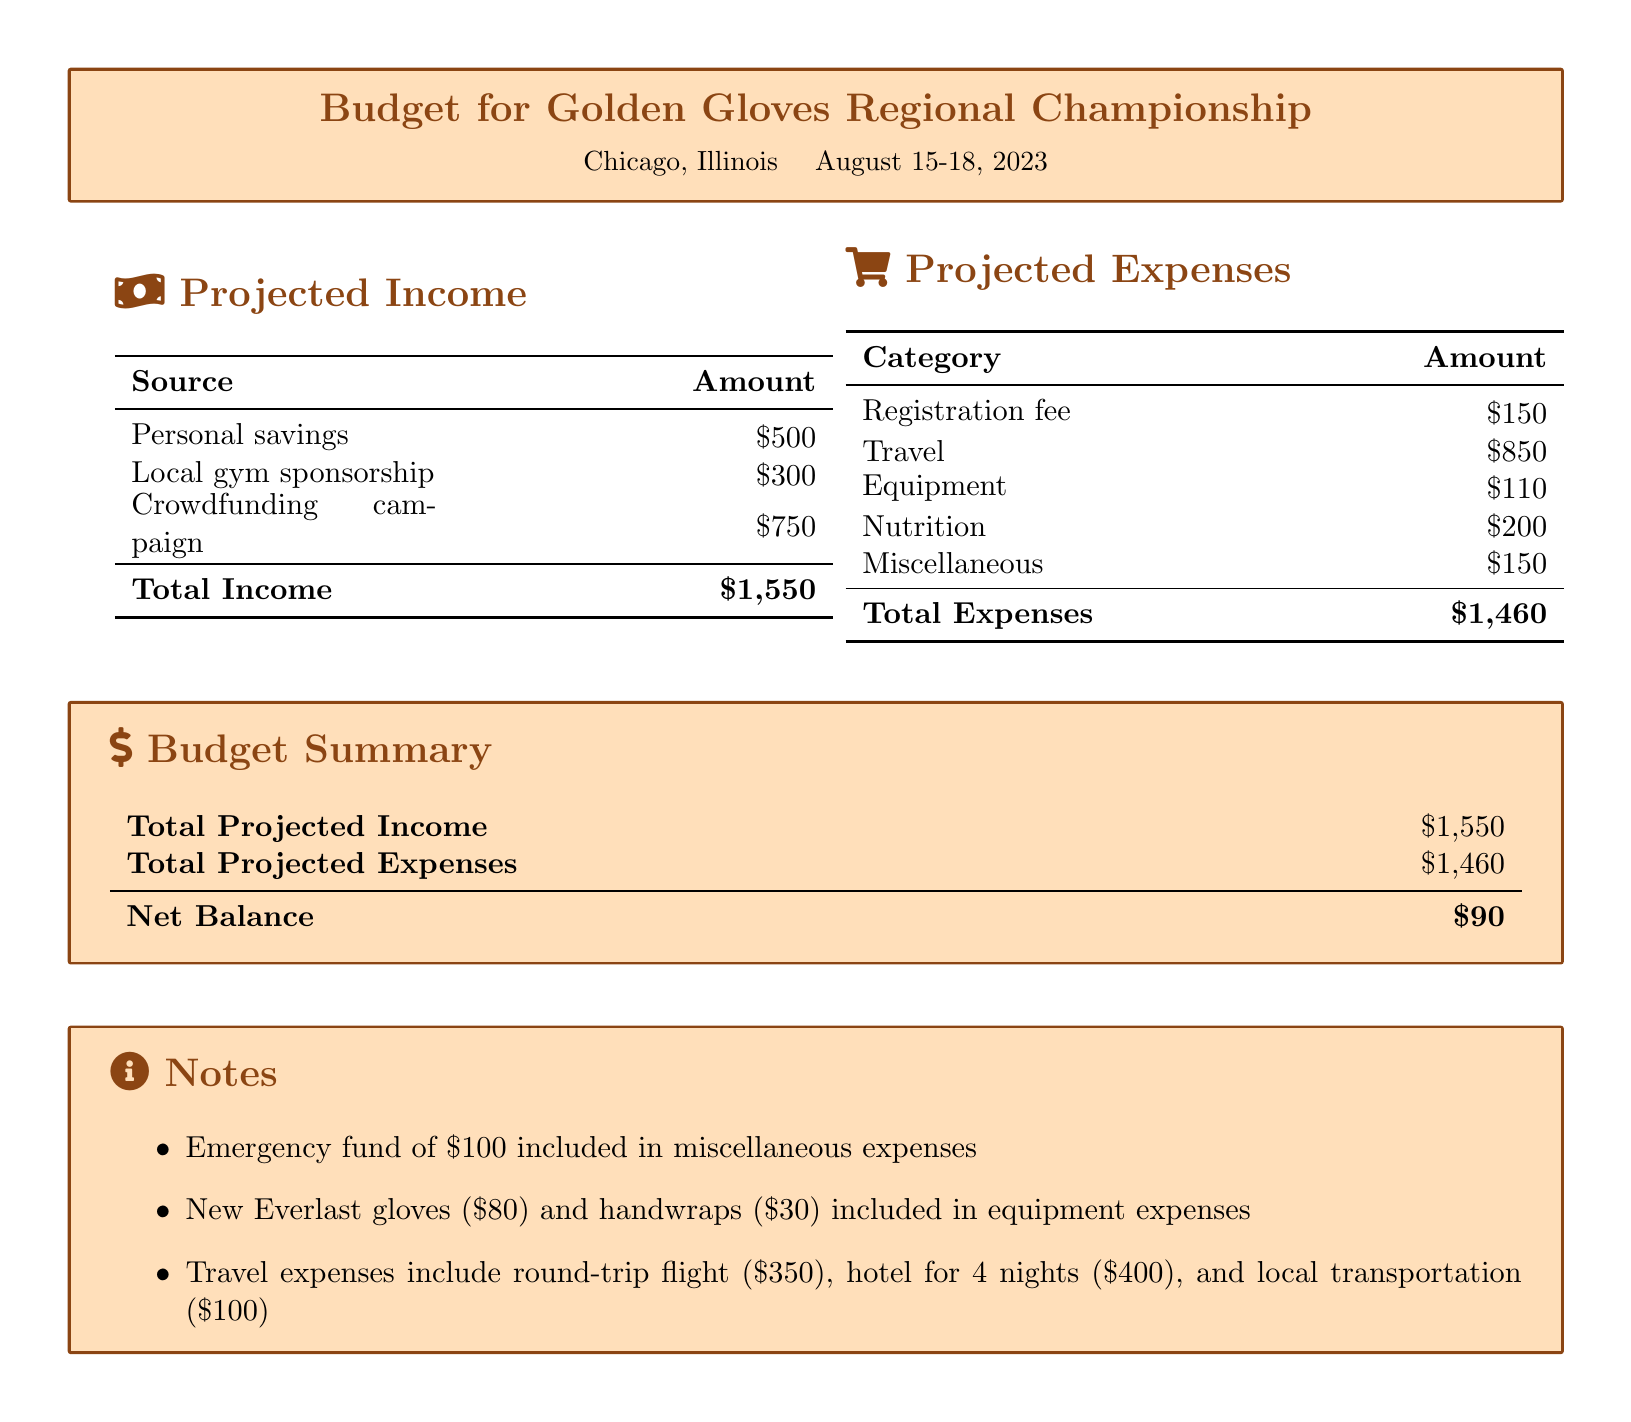What is the total projected income? The total projected income is calculated by adding personal savings, gym sponsorship, and crowdfunding.
Answer: $1,550 What is the registration fee? The registration fee is specifically listed under projected expenses in the document.
Answer: $150 What is included in the miscellaneous expenses? The notes section mentions an emergency fund as part of miscellaneous expenses.
Answer: $100 How much is allocated for travel? The travel amount is detailed in the projected expenses section.
Answer: $850 What is the net balance? The net balance is calculated by subtracting total expenses from total income.
Answer: $90 What is the amount spent on nutrition? The nutrition amount is explicitly stated in the projected expenses.
Answer: $200 How many nights is the hotel stay? The document states the hotel is for 4 nights, included under travel expenses.
Answer: 4 nights What brand of gloves is mentioned? The notes section specifically mentions "Everlast" gloves.
Answer: Everlast What was the total cost of equipment? The equipment total is presented as a single amount under projected expenses.
Answer: $110 What is the crowdfunding campaign amount? The crowdfunding campaign amount is listed under projected income in the document.
Answer: $750 